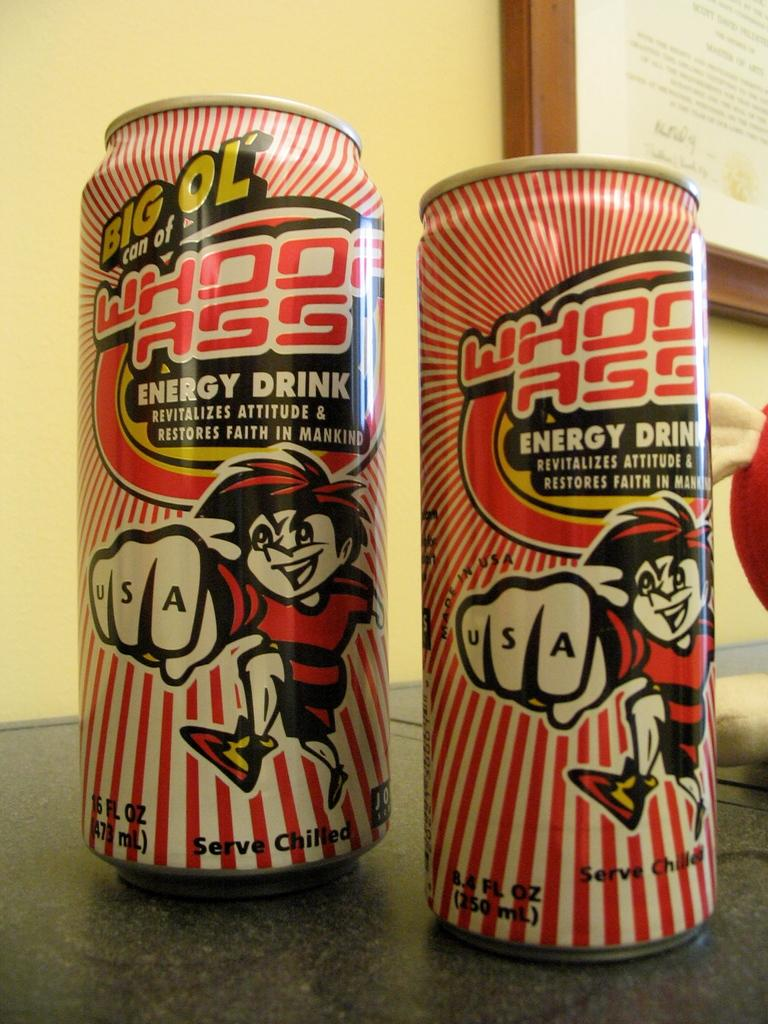<image>
Summarize the visual content of the image. the word big is on a red and white can 